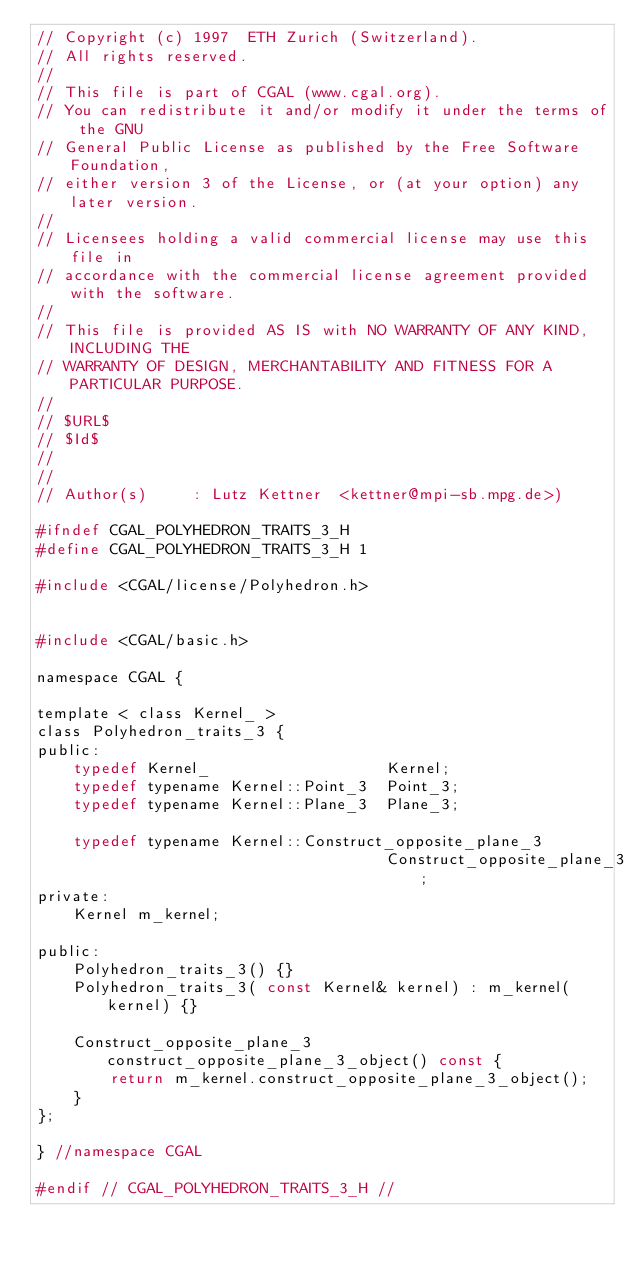<code> <loc_0><loc_0><loc_500><loc_500><_C_>// Copyright (c) 1997  ETH Zurich (Switzerland).
// All rights reserved.
//
// This file is part of CGAL (www.cgal.org).
// You can redistribute it and/or modify it under the terms of the GNU
// General Public License as published by the Free Software Foundation,
// either version 3 of the License, or (at your option) any later version.
//
// Licensees holding a valid commercial license may use this file in
// accordance with the commercial license agreement provided with the software.
//
// This file is provided AS IS with NO WARRANTY OF ANY KIND, INCLUDING THE
// WARRANTY OF DESIGN, MERCHANTABILITY AND FITNESS FOR A PARTICULAR PURPOSE.
//
// $URL$
// $Id$
// 
//
// Author(s)     : Lutz Kettner  <kettner@mpi-sb.mpg.de>)

#ifndef CGAL_POLYHEDRON_TRAITS_3_H
#define CGAL_POLYHEDRON_TRAITS_3_H 1

#include <CGAL/license/Polyhedron.h>


#include <CGAL/basic.h>

namespace CGAL {

template < class Kernel_ >
class Polyhedron_traits_3 {
public:
    typedef Kernel_                   Kernel;
    typedef typename Kernel::Point_3  Point_3;
    typedef typename Kernel::Plane_3  Plane_3;

    typedef typename Kernel::Construct_opposite_plane_3 
                                      Construct_opposite_plane_3;
private:
    Kernel m_kernel;

public:
    Polyhedron_traits_3() {}
    Polyhedron_traits_3( const Kernel& kernel) : m_kernel(kernel) {}

    Construct_opposite_plane_3 construct_opposite_plane_3_object() const {
        return m_kernel.construct_opposite_plane_3_object();
    }
};

} //namespace CGAL

#endif // CGAL_POLYHEDRON_TRAITS_3_H //
</code> 